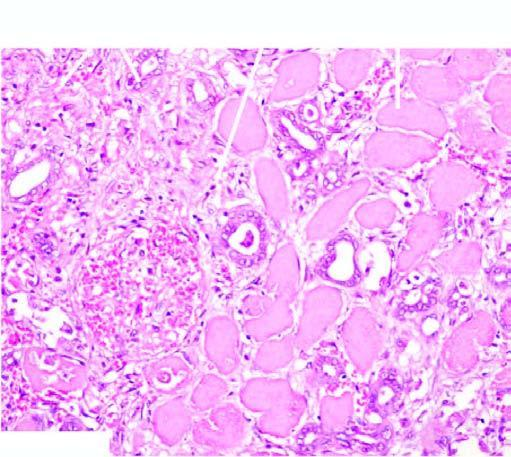what show typical coagulative necrosis?
Answer the question using a single word or phrase. Renal tubules and glomeruli 